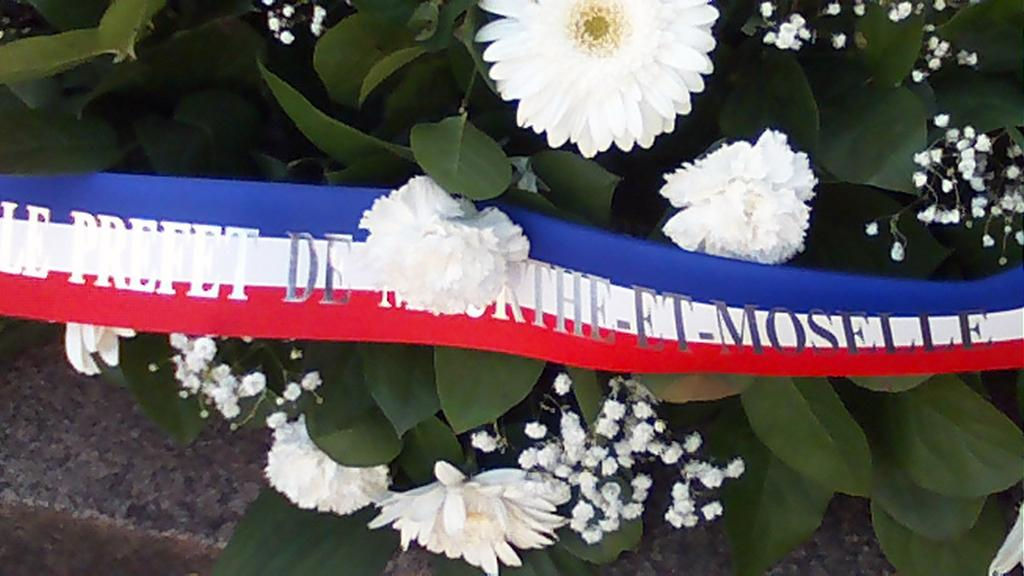What type of plants can be seen in the image? There are plants with flowers in the image. Can you describe any additional features of the plants? The plants have flowers, which suggests they are blooming or in a flowering stage. What else is present in the image besides the plants? There is a ribbon with text on it in the image. What type of cheese is being used to build the lumber structure in the image? There is no cheese or lumber structure present in the image. 